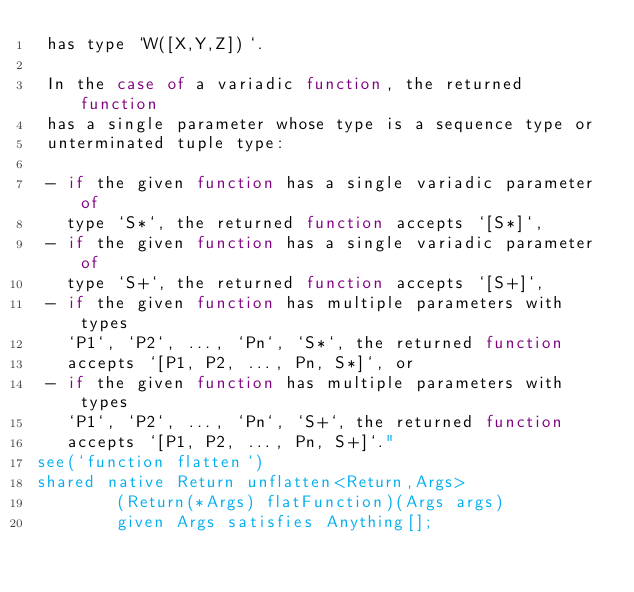<code> <loc_0><loc_0><loc_500><loc_500><_Ceylon_> has type `W([X,Y,Z])`.
 
 In the case of a variadic function, the returned function 
 has a single parameter whose type is a sequence type or 
 unterminated tuple type:
 
 - if the given function has a single variadic parameter of 
   type `S*`, the returned function accepts `[S*]`,
 - if the given function has a single variadic parameter of 
   type `S+`, the returned function accepts `[S+]`,
 - if the given function has multiple parameters with types
   `P1`, `P2`, ..., `Pn`, `S*`, the returned function 
   accepts `[P1, P2, ..., Pn, S*]`, or
 - if the given function has multiple parameters with types
   `P1`, `P2`, ..., `Pn`, `S+`, the returned function 
   accepts `[P1, P2, ..., Pn, S+]`."
see(`function flatten`)
shared native Return unflatten<Return,Args>
        (Return(*Args) flatFunction)(Args args)
        given Args satisfies Anything[];
</code> 